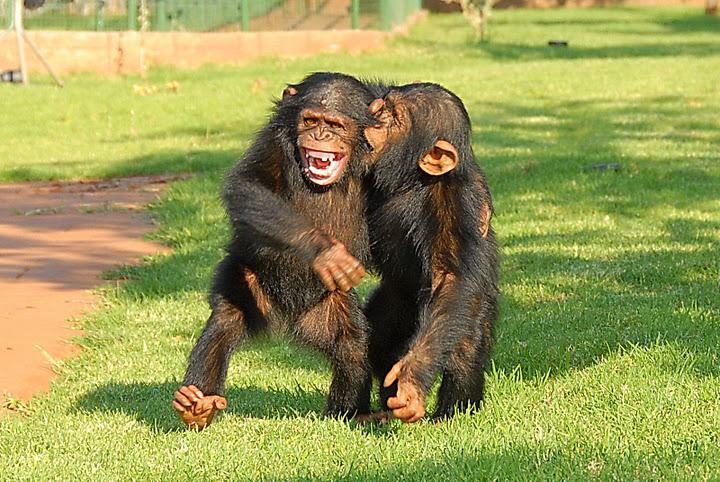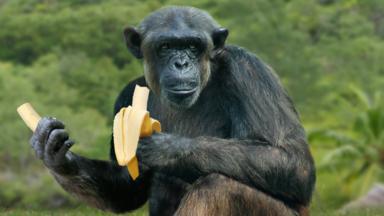The first image is the image on the left, the second image is the image on the right. Assess this claim about the two images: "There are at most two chimpanzees.". Correct or not? Answer yes or no. No. 